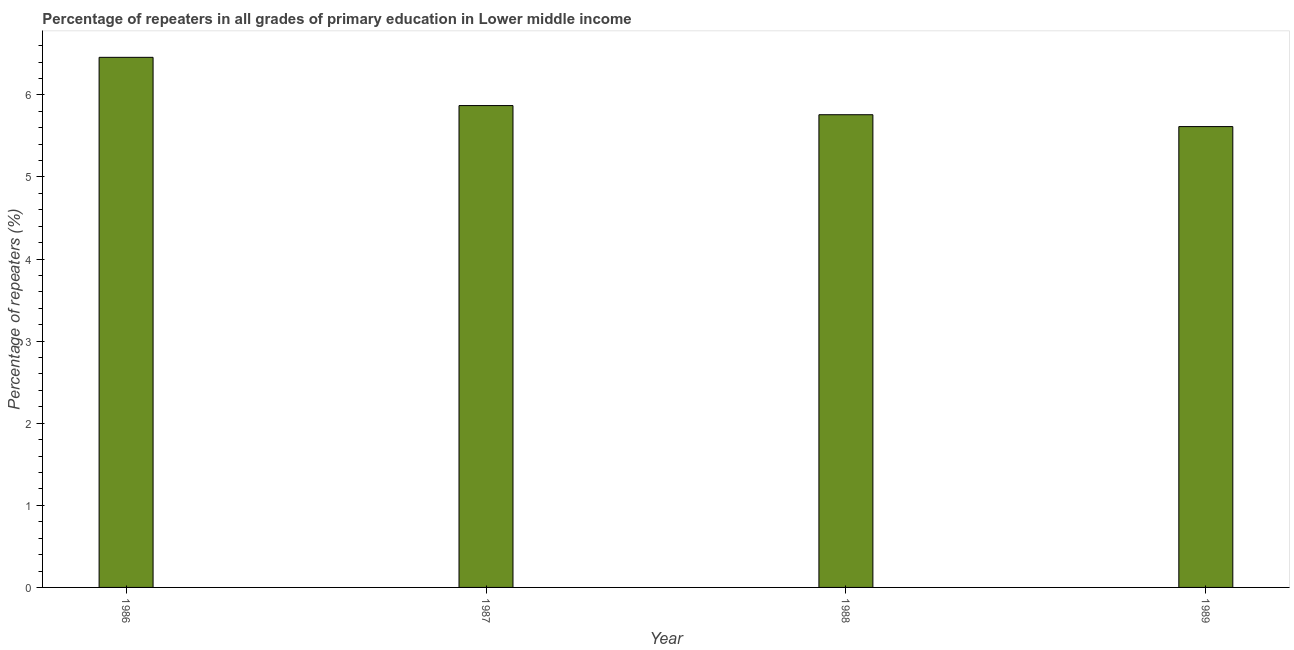Does the graph contain any zero values?
Your response must be concise. No. What is the title of the graph?
Provide a short and direct response. Percentage of repeaters in all grades of primary education in Lower middle income. What is the label or title of the Y-axis?
Offer a very short reply. Percentage of repeaters (%). What is the percentage of repeaters in primary education in 1987?
Provide a succinct answer. 5.87. Across all years, what is the maximum percentage of repeaters in primary education?
Provide a short and direct response. 6.46. Across all years, what is the minimum percentage of repeaters in primary education?
Your response must be concise. 5.61. In which year was the percentage of repeaters in primary education maximum?
Provide a short and direct response. 1986. What is the sum of the percentage of repeaters in primary education?
Provide a short and direct response. 23.7. What is the difference between the percentage of repeaters in primary education in 1986 and 1987?
Your answer should be very brief. 0.59. What is the average percentage of repeaters in primary education per year?
Give a very brief answer. 5.92. What is the median percentage of repeaters in primary education?
Your answer should be compact. 5.81. In how many years, is the percentage of repeaters in primary education greater than 0.6 %?
Give a very brief answer. 4. Do a majority of the years between 1988 and 1989 (inclusive) have percentage of repeaters in primary education greater than 1 %?
Your answer should be compact. Yes. What is the ratio of the percentage of repeaters in primary education in 1986 to that in 1987?
Your answer should be very brief. 1.1. Is the percentage of repeaters in primary education in 1986 less than that in 1987?
Your answer should be very brief. No. What is the difference between the highest and the second highest percentage of repeaters in primary education?
Offer a very short reply. 0.59. What is the difference between the highest and the lowest percentage of repeaters in primary education?
Ensure brevity in your answer.  0.84. In how many years, is the percentage of repeaters in primary education greater than the average percentage of repeaters in primary education taken over all years?
Your answer should be compact. 1. How many years are there in the graph?
Provide a short and direct response. 4. What is the Percentage of repeaters (%) in 1986?
Provide a short and direct response. 6.46. What is the Percentage of repeaters (%) of 1987?
Provide a short and direct response. 5.87. What is the Percentage of repeaters (%) in 1988?
Give a very brief answer. 5.76. What is the Percentage of repeaters (%) in 1989?
Provide a succinct answer. 5.61. What is the difference between the Percentage of repeaters (%) in 1986 and 1987?
Your answer should be very brief. 0.59. What is the difference between the Percentage of repeaters (%) in 1986 and 1988?
Ensure brevity in your answer.  0.7. What is the difference between the Percentage of repeaters (%) in 1986 and 1989?
Provide a short and direct response. 0.84. What is the difference between the Percentage of repeaters (%) in 1987 and 1988?
Your answer should be compact. 0.11. What is the difference between the Percentage of repeaters (%) in 1987 and 1989?
Offer a very short reply. 0.26. What is the difference between the Percentage of repeaters (%) in 1988 and 1989?
Keep it short and to the point. 0.14. What is the ratio of the Percentage of repeaters (%) in 1986 to that in 1988?
Your response must be concise. 1.12. What is the ratio of the Percentage of repeaters (%) in 1986 to that in 1989?
Make the answer very short. 1.15. What is the ratio of the Percentage of repeaters (%) in 1987 to that in 1988?
Provide a short and direct response. 1.02. What is the ratio of the Percentage of repeaters (%) in 1987 to that in 1989?
Offer a terse response. 1.05. What is the ratio of the Percentage of repeaters (%) in 1988 to that in 1989?
Your response must be concise. 1.03. 